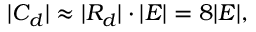<formula> <loc_0><loc_0><loc_500><loc_500>| C _ { d } | \approx | R _ { d } | \cdot | E | = 8 | E | ,</formula> 